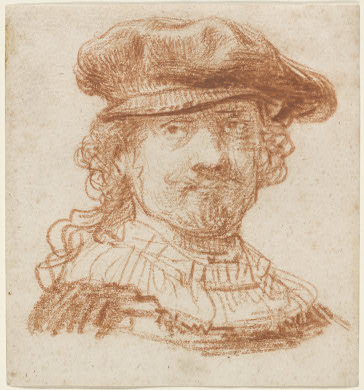Can you explore the emotional or psychological depth conveyed in this portrait? The man's expression, a mix of a subtle smile and direct gaze, suggests a complex emotional state. The artist captures a hint of assuredness, possibly confidence or intellect, mixed with a touch of approachability. This balanced emotional depiction can invite viewers to ponder about the subject’s thoughts or feelings at the moment of capture, making it both psychologically dense and personally engaging. 